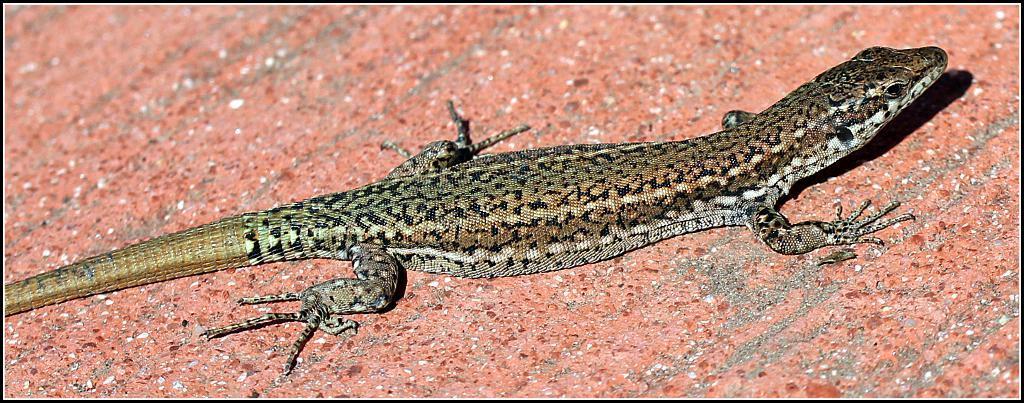Describe this image in one or two sentences. In this image I can see a lizard on a surface. 